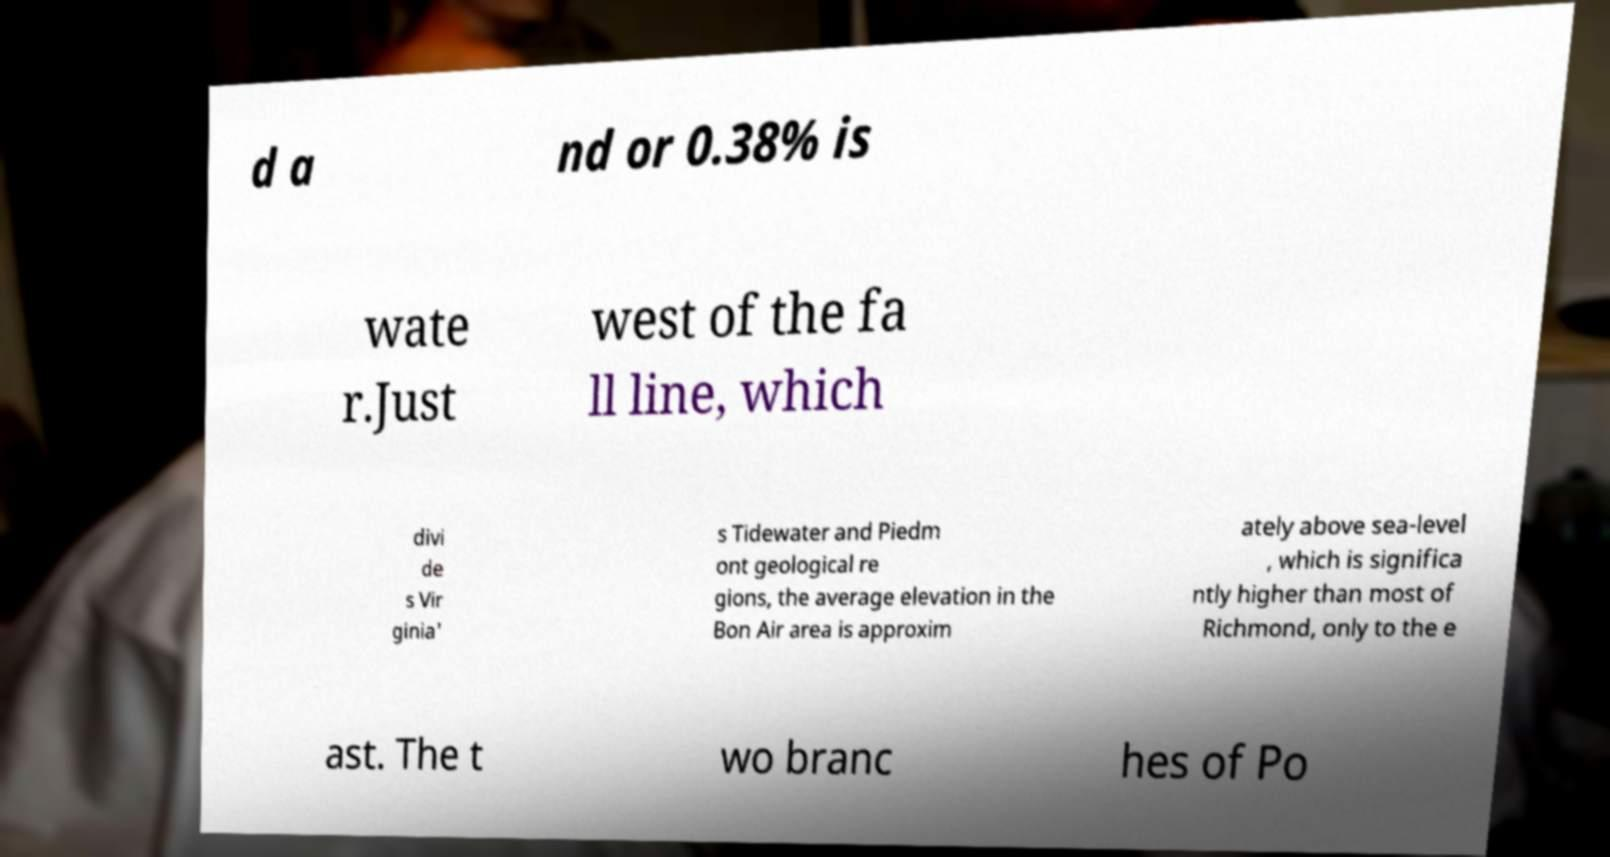Please read and relay the text visible in this image. What does it say? d a nd or 0.38% is wate r.Just west of the fa ll line, which divi de s Vir ginia' s Tidewater and Piedm ont geological re gions, the average elevation in the Bon Air area is approxim ately above sea-level , which is significa ntly higher than most of Richmond, only to the e ast. The t wo branc hes of Po 